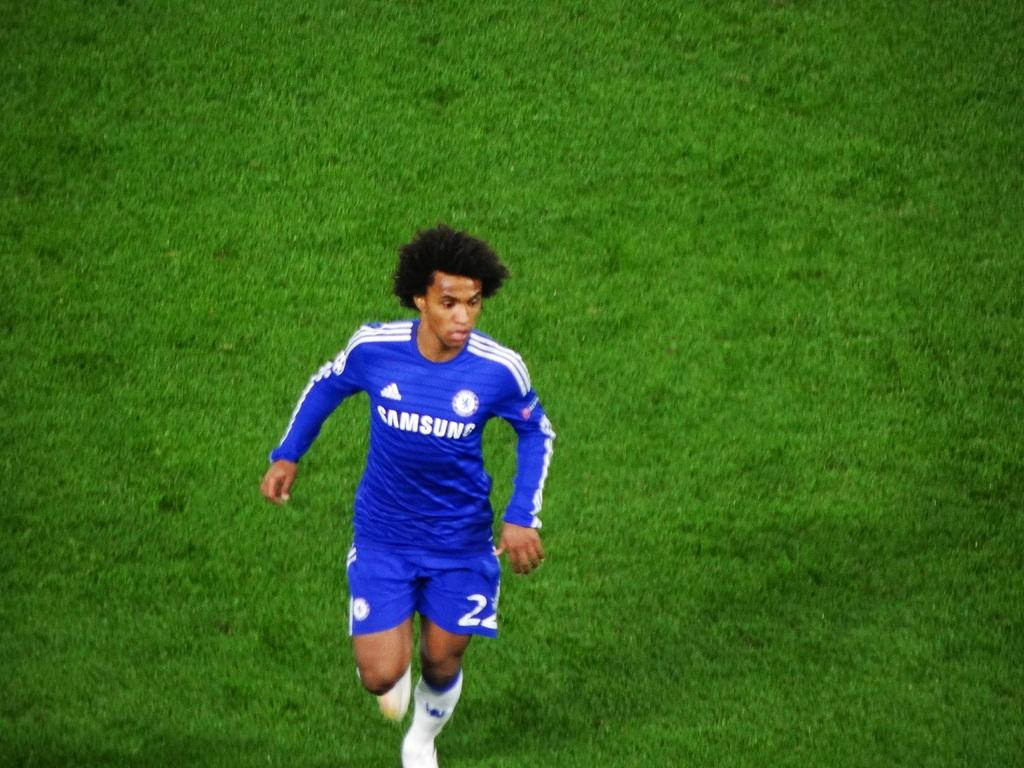<image>
Create a compact narrative representing the image presented. A man in a blue Samsung uniform jogs across the field. 